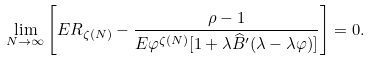Convert formula to latex. <formula><loc_0><loc_0><loc_500><loc_500>\lim _ { N \to \infty } \left [ E R _ { \zeta ( N ) } - \frac { \rho - 1 } { E \varphi ^ { \zeta ( N ) } [ 1 + \lambda \widehat { B } ^ { \prime } ( \lambda - \lambda \varphi ) ] } \right ] = 0 .</formula> 